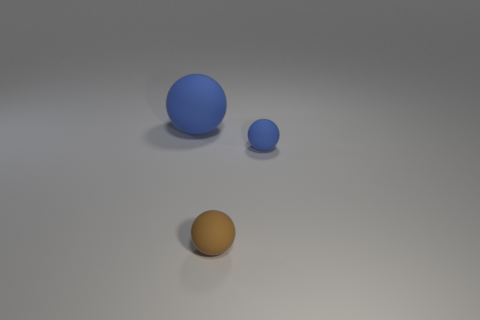Subtract all small matte balls. How many balls are left? 1 Subtract all yellow blocks. How many blue balls are left? 2 Add 2 tiny brown rubber objects. How many objects exist? 5 Subtract all gray balls. Subtract all purple blocks. How many balls are left? 3 Subtract 0 green cubes. How many objects are left? 3 Subtract all big purple metallic cylinders. Subtract all blue objects. How many objects are left? 1 Add 2 brown rubber objects. How many brown rubber objects are left? 3 Add 1 tiny brown matte balls. How many tiny brown matte balls exist? 2 